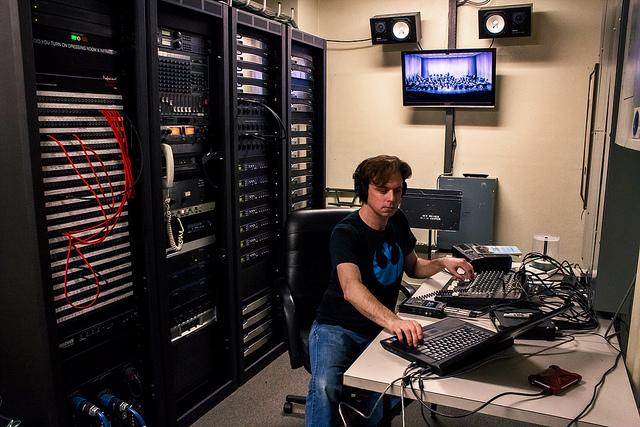What is behind the man?
Quick response, please. Server. What color is the man's shirt?
Concise answer only. Black. Do you think this man is a computer engineer?
Keep it brief. Yes. What color is the man's pants?
Short answer required. Blue. What is around his neck?
Quick response, please. Nothing. 